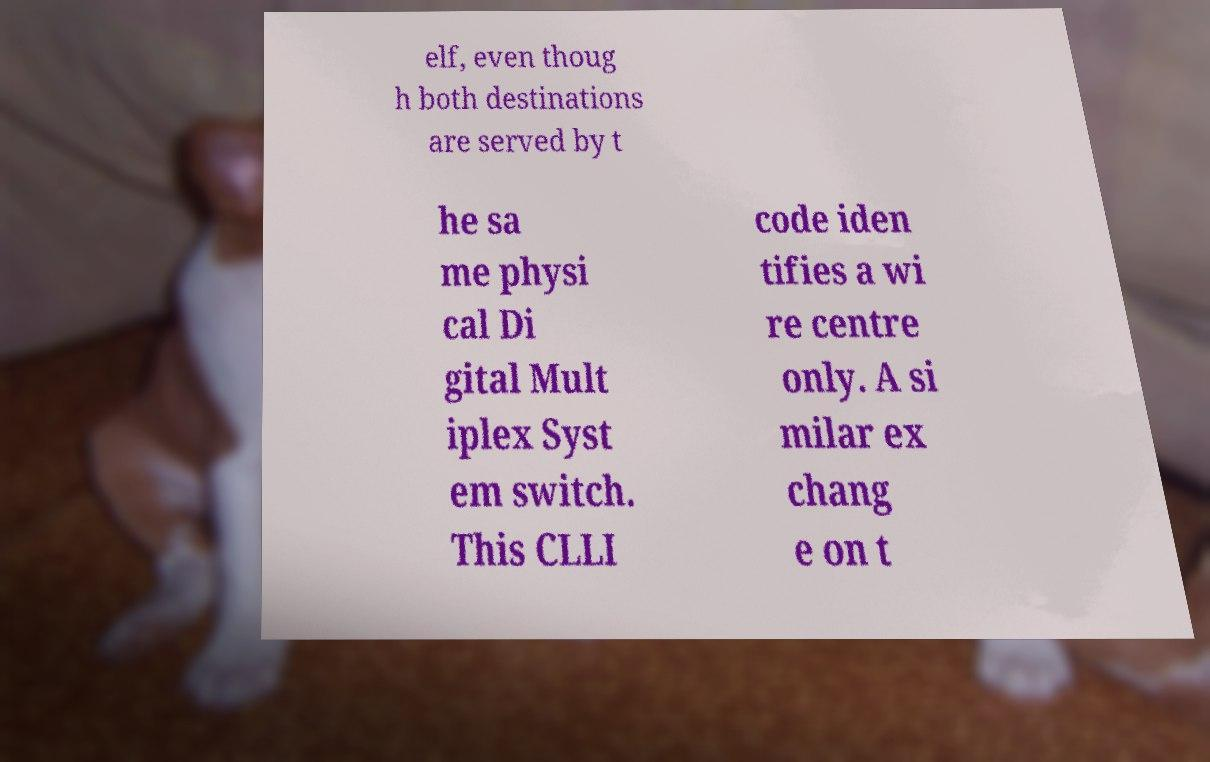I need the written content from this picture converted into text. Can you do that? elf, even thoug h both destinations are served by t he sa me physi cal Di gital Mult iplex Syst em switch. This CLLI code iden tifies a wi re centre only. A si milar ex chang e on t 